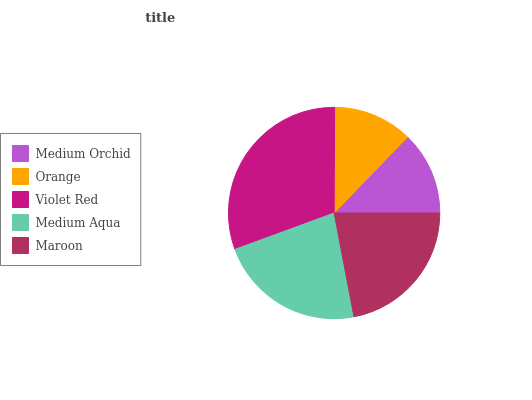Is Orange the minimum?
Answer yes or no. Yes. Is Violet Red the maximum?
Answer yes or no. Yes. Is Violet Red the minimum?
Answer yes or no. No. Is Orange the maximum?
Answer yes or no. No. Is Violet Red greater than Orange?
Answer yes or no. Yes. Is Orange less than Violet Red?
Answer yes or no. Yes. Is Orange greater than Violet Red?
Answer yes or no. No. Is Violet Red less than Orange?
Answer yes or no. No. Is Maroon the high median?
Answer yes or no. Yes. Is Maroon the low median?
Answer yes or no. Yes. Is Orange the high median?
Answer yes or no. No. Is Violet Red the low median?
Answer yes or no. No. 